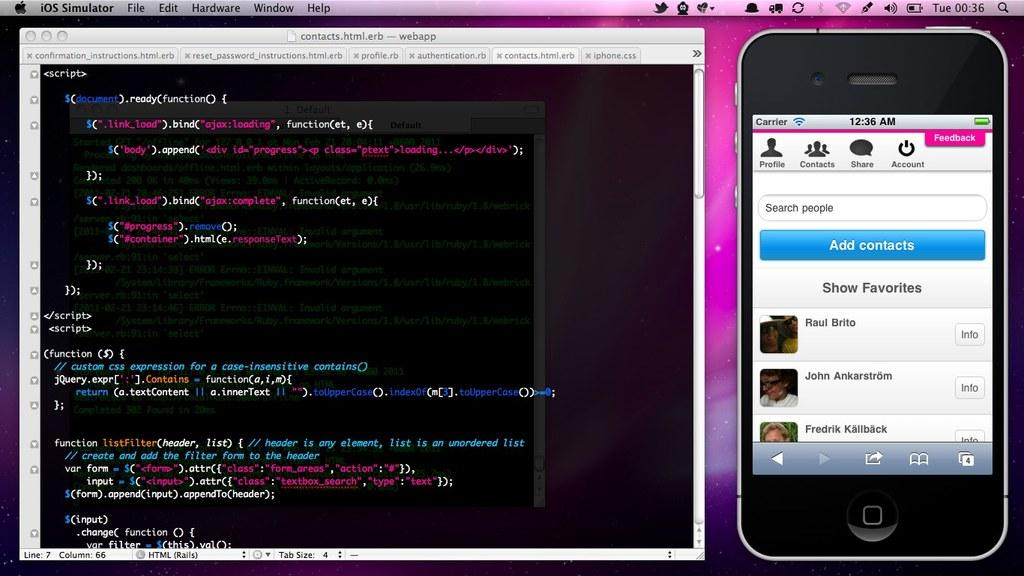<image>
Describe the image concisely. A monitor shows the codes for the contacts.html.erb next to a smartphone contacts. 